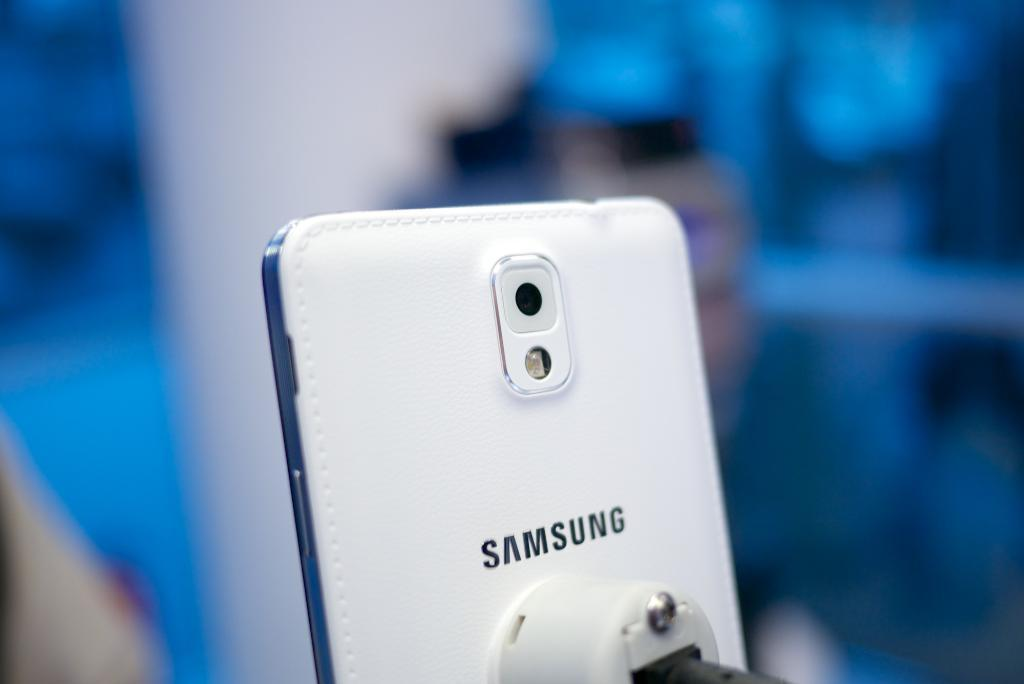Provide a one-sentence caption for the provided image. The back of a Samsung phone features a stitched white leather cover. 